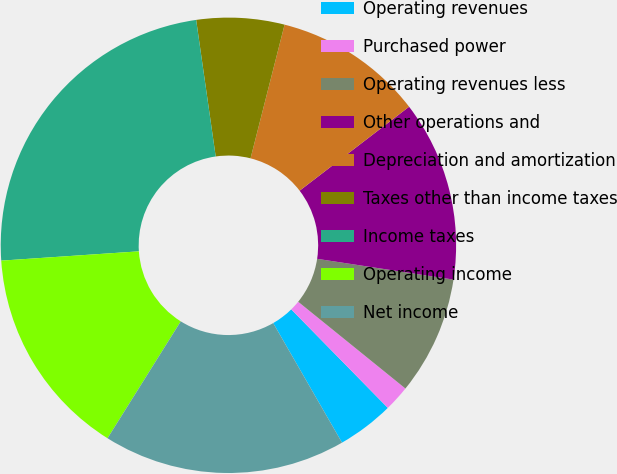Convert chart. <chart><loc_0><loc_0><loc_500><loc_500><pie_chart><fcel>Operating revenues<fcel>Purchased power<fcel>Operating revenues less<fcel>Other operations and<fcel>Depreciation and amortization<fcel>Taxes other than income taxes<fcel>Income taxes<fcel>Operating income<fcel>Net income<nl><fcel>4.03%<fcel>1.83%<fcel>8.42%<fcel>12.82%<fcel>10.62%<fcel>6.23%<fcel>23.81%<fcel>15.02%<fcel>17.22%<nl></chart> 